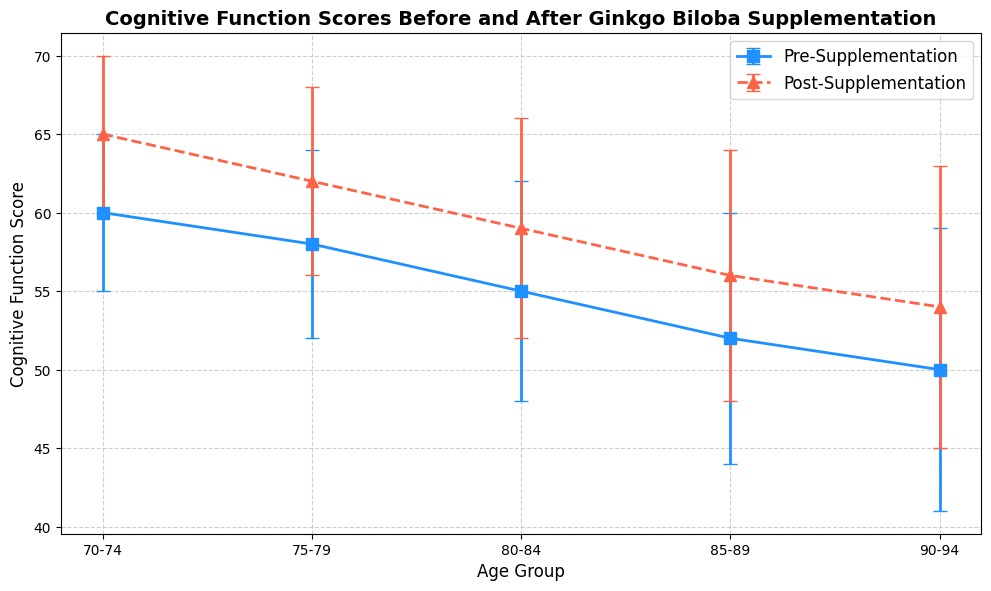What age group shows the largest improvement in cognitive function scores after supplementing with Ginkgo Biloba? Look at the difference between pre-supplement and post-supplement scores for each age group. The 70-74 age group has an improvement of 65 - 60 = 5, the 75-79 group has 62 - 58 = 4, the 80-84 group has 59 - 55 = 4, the 85-89 group has 56 - 52 = 4, and the 90-94 group has 54 - 50 = 4. So, the 70-74 age group shows the largest improvement.
Answer: 70-74 Which age group has the lowest pre-supplement cognitive function score? Identify the smallest pre-supplement mean score from the plot. The scores are 60, 58, 55, 52, and 50 for the age groups. The lowest is 50 for the 90-94 age group.
Answer: 90-94 Between which two age groups is the difference in post-supplement scores the greatest? Compare the post-supplement scores: 65 for 70-74, 62 for 75-79, 59 for 80-84, 56 for 85-89, and 54 for 90-94. The greatest difference is between the 70-74 and 90-94 age groups, which is 65 - 54 = 11.
Answer: 70-74 and 90-94 How does the standard deviation of pre-supplement scores change with increasing age? Observe the pattern in the standard deviations of pre-supplement scores (5, 6, 7, 8, 9) across the age groups (70-74, 75-79, 80-84, 85-89, 90-94). The standard deviation increases steadily with age.
Answer: Increases Which group shows a more consistent cognitive function score, pre-supplement or post-supplement? Look at the error bars representing standard deviations for pre-supplement and post-supplement scores. Both show error bars of equal lengths for corresponding age groups; hence, the consistency is the same.
Answer: Same 